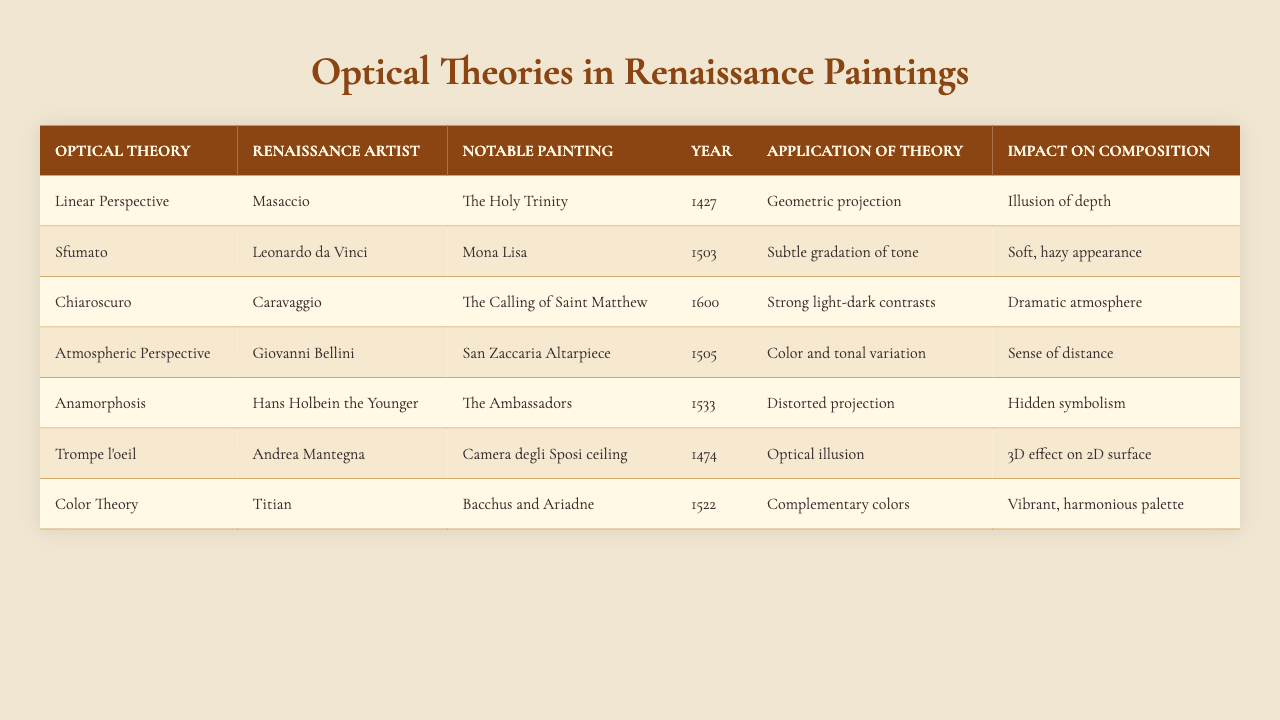What is the notable painting by Leonardo da Vinci mentioned in the table? The table lists several artists and their notable paintings. By locating Leonardo da Vinci in the row, I can see that his notable painting is the Mona Lisa.
Answer: Mona Lisa Which optical theory is applied in Masaccio's "The Holy Trinity"? Looking at the row for Masaccio, it is evident that the optical theory applied in "The Holy Trinity" is Linear Perspective.
Answer: Linear Perspective What year was "The Ambassadors" created by Hans Holbein the Younger? By directly referencing the row for Hans Holbein the Younger, I find that "The Ambassadors" was created in the year 1533.
Answer: 1533 Which artist is associated with the optical theory of Sfumato? The table provides a clear list of artists and their corresponding optical theories. Leonardo da Vinci is the artist associated with Sfumato.
Answer: Leonardo da Vinci How many artworks mentioned in the table are associated with the optical theory of Chiaroscuro? The table indicates that only one artwork, "The Calling of Saint Matthew," is associated with the optical theory of Chiaroscuro based on Caravaggio's row.
Answer: 1 Is Atmospheric Perspective used in any paintings? By examining the rows, I can confirm that Giovanni Bellini's "San Zaccaria Altarpiece" utilizes Atmospheric Perspective, validating that the theory is indeed used in paintings.
Answer: Yes What impact does the application of Color Theory have on Titian's artwork? In Titian's row, the impact of Color Theory is described as a vibrant, harmonious palette, indicating a positive effect in the composition of the painting.
Answer: Vibrant, harmonious palette Can we identify two artists who applied optical theories related to creating depth in their compositions? Analyzing the table, Masaccio with Linear Perspective and Giovanni Bellini with Atmospheric Perspective both clearly focus on creating depth.
Answer: Masaccio and Giovanni Bellini What is the main application of Anamorphosis in Hans Holbein the Younger's "The Ambassadors"? The table indicates that the application of Anamorphosis in "The Ambassadors" involves a distorted projection, serving a particular artistic purpose.
Answer: Distorted projection Which painting makes use of Trompe l'oeil and who created it? The table shows that Andrea Mantegna created the "Camera degli Sposi ceiling," where Trompe l'oeil is applied for effective optical illusion.
Answer: Camera degli Sposi ceiling by Andrea Mantegna 